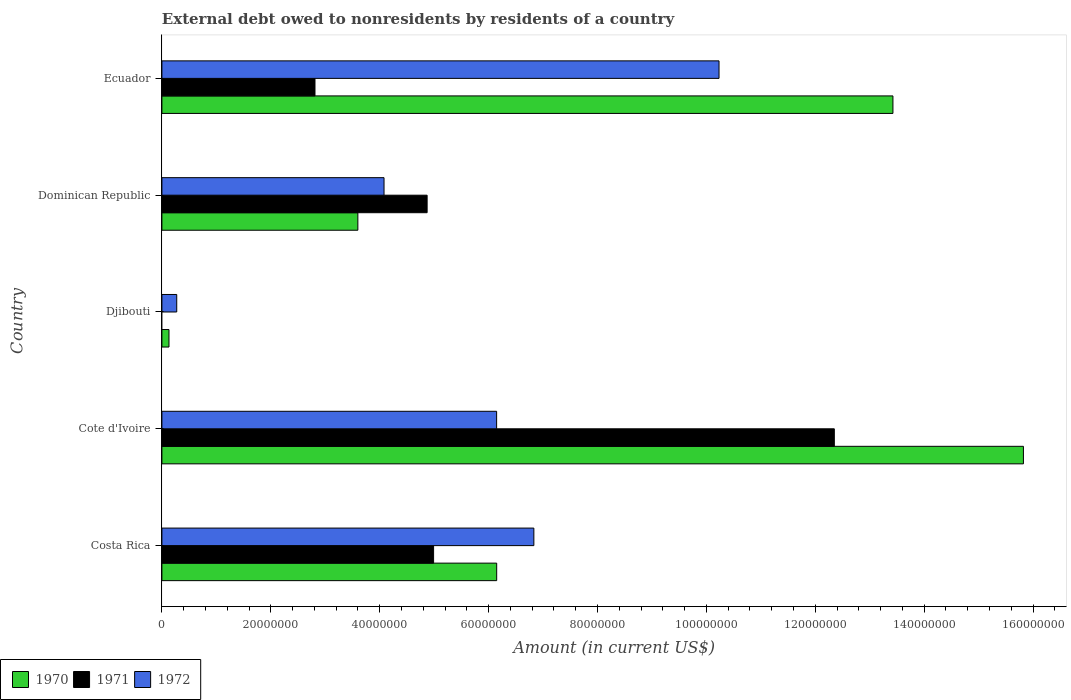Are the number of bars per tick equal to the number of legend labels?
Ensure brevity in your answer.  No. What is the label of the 2nd group of bars from the top?
Make the answer very short. Dominican Republic. In how many cases, is the number of bars for a given country not equal to the number of legend labels?
Your answer should be compact. 1. What is the external debt owed by residents in 1971 in Costa Rica?
Provide a short and direct response. 4.99e+07. Across all countries, what is the maximum external debt owed by residents in 1970?
Your answer should be compact. 1.58e+08. Across all countries, what is the minimum external debt owed by residents in 1972?
Provide a short and direct response. 2.72e+06. In which country was the external debt owed by residents in 1971 maximum?
Keep it short and to the point. Cote d'Ivoire. What is the total external debt owed by residents in 1972 in the graph?
Your answer should be very brief. 2.76e+08. What is the difference between the external debt owed by residents in 1971 in Dominican Republic and that in Ecuador?
Ensure brevity in your answer.  2.06e+07. What is the difference between the external debt owed by residents in 1970 in Djibouti and the external debt owed by residents in 1971 in Dominican Republic?
Keep it short and to the point. -4.74e+07. What is the average external debt owed by residents in 1972 per country?
Provide a short and direct response. 5.51e+07. What is the difference between the external debt owed by residents in 1971 and external debt owed by residents in 1972 in Ecuador?
Offer a very short reply. -7.42e+07. What is the ratio of the external debt owed by residents in 1972 in Djibouti to that in Ecuador?
Ensure brevity in your answer.  0.03. Is the external debt owed by residents in 1970 in Costa Rica less than that in Ecuador?
Your response must be concise. Yes. Is the difference between the external debt owed by residents in 1971 in Cote d'Ivoire and Ecuador greater than the difference between the external debt owed by residents in 1972 in Cote d'Ivoire and Ecuador?
Your response must be concise. Yes. What is the difference between the highest and the second highest external debt owed by residents in 1970?
Your answer should be compact. 2.40e+07. What is the difference between the highest and the lowest external debt owed by residents in 1971?
Your answer should be compact. 1.23e+08. In how many countries, is the external debt owed by residents in 1972 greater than the average external debt owed by residents in 1972 taken over all countries?
Give a very brief answer. 3. Is the sum of the external debt owed by residents in 1970 in Cote d'Ivoire and Ecuador greater than the maximum external debt owed by residents in 1972 across all countries?
Make the answer very short. Yes. How many bars are there?
Provide a succinct answer. 14. How many countries are there in the graph?
Your response must be concise. 5. Are the values on the major ticks of X-axis written in scientific E-notation?
Provide a succinct answer. No. Does the graph contain grids?
Provide a succinct answer. No. Where does the legend appear in the graph?
Give a very brief answer. Bottom left. What is the title of the graph?
Give a very brief answer. External debt owed to nonresidents by residents of a country. What is the Amount (in current US$) of 1970 in Costa Rica?
Ensure brevity in your answer.  6.15e+07. What is the Amount (in current US$) of 1971 in Costa Rica?
Your answer should be compact. 4.99e+07. What is the Amount (in current US$) of 1972 in Costa Rica?
Your answer should be compact. 6.83e+07. What is the Amount (in current US$) in 1970 in Cote d'Ivoire?
Your answer should be compact. 1.58e+08. What is the Amount (in current US$) in 1971 in Cote d'Ivoire?
Ensure brevity in your answer.  1.23e+08. What is the Amount (in current US$) of 1972 in Cote d'Ivoire?
Offer a very short reply. 6.15e+07. What is the Amount (in current US$) of 1970 in Djibouti?
Your answer should be very brief. 1.30e+06. What is the Amount (in current US$) of 1971 in Djibouti?
Provide a succinct answer. 0. What is the Amount (in current US$) of 1972 in Djibouti?
Make the answer very short. 2.72e+06. What is the Amount (in current US$) in 1970 in Dominican Republic?
Keep it short and to the point. 3.60e+07. What is the Amount (in current US$) of 1971 in Dominican Republic?
Ensure brevity in your answer.  4.87e+07. What is the Amount (in current US$) of 1972 in Dominican Republic?
Give a very brief answer. 4.08e+07. What is the Amount (in current US$) of 1970 in Ecuador?
Make the answer very short. 1.34e+08. What is the Amount (in current US$) in 1971 in Ecuador?
Give a very brief answer. 2.81e+07. What is the Amount (in current US$) in 1972 in Ecuador?
Provide a short and direct response. 1.02e+08. Across all countries, what is the maximum Amount (in current US$) of 1970?
Offer a terse response. 1.58e+08. Across all countries, what is the maximum Amount (in current US$) of 1971?
Your answer should be very brief. 1.23e+08. Across all countries, what is the maximum Amount (in current US$) in 1972?
Your answer should be compact. 1.02e+08. Across all countries, what is the minimum Amount (in current US$) of 1970?
Offer a terse response. 1.30e+06. Across all countries, what is the minimum Amount (in current US$) in 1971?
Give a very brief answer. 0. Across all countries, what is the minimum Amount (in current US$) of 1972?
Ensure brevity in your answer.  2.72e+06. What is the total Amount (in current US$) in 1970 in the graph?
Your answer should be compact. 3.91e+08. What is the total Amount (in current US$) of 1971 in the graph?
Give a very brief answer. 2.50e+08. What is the total Amount (in current US$) in 1972 in the graph?
Give a very brief answer. 2.76e+08. What is the difference between the Amount (in current US$) of 1970 in Costa Rica and that in Cote d'Ivoire?
Your answer should be compact. -9.67e+07. What is the difference between the Amount (in current US$) in 1971 in Costa Rica and that in Cote d'Ivoire?
Your response must be concise. -7.36e+07. What is the difference between the Amount (in current US$) in 1972 in Costa Rica and that in Cote d'Ivoire?
Ensure brevity in your answer.  6.84e+06. What is the difference between the Amount (in current US$) in 1970 in Costa Rica and that in Djibouti?
Make the answer very short. 6.02e+07. What is the difference between the Amount (in current US$) in 1972 in Costa Rica and that in Djibouti?
Your response must be concise. 6.56e+07. What is the difference between the Amount (in current US$) of 1970 in Costa Rica and that in Dominican Republic?
Provide a short and direct response. 2.55e+07. What is the difference between the Amount (in current US$) in 1971 in Costa Rica and that in Dominican Republic?
Ensure brevity in your answer.  1.19e+06. What is the difference between the Amount (in current US$) of 1972 in Costa Rica and that in Dominican Republic?
Offer a very short reply. 2.75e+07. What is the difference between the Amount (in current US$) in 1970 in Costa Rica and that in Ecuador?
Provide a short and direct response. -7.28e+07. What is the difference between the Amount (in current US$) of 1971 in Costa Rica and that in Ecuador?
Your answer should be compact. 2.18e+07. What is the difference between the Amount (in current US$) of 1972 in Costa Rica and that in Ecuador?
Provide a short and direct response. -3.40e+07. What is the difference between the Amount (in current US$) in 1970 in Cote d'Ivoire and that in Djibouti?
Ensure brevity in your answer.  1.57e+08. What is the difference between the Amount (in current US$) in 1972 in Cote d'Ivoire and that in Djibouti?
Provide a short and direct response. 5.88e+07. What is the difference between the Amount (in current US$) of 1970 in Cote d'Ivoire and that in Dominican Republic?
Give a very brief answer. 1.22e+08. What is the difference between the Amount (in current US$) in 1971 in Cote d'Ivoire and that in Dominican Republic?
Provide a short and direct response. 7.48e+07. What is the difference between the Amount (in current US$) in 1972 in Cote d'Ivoire and that in Dominican Republic?
Offer a very short reply. 2.07e+07. What is the difference between the Amount (in current US$) of 1970 in Cote d'Ivoire and that in Ecuador?
Offer a terse response. 2.40e+07. What is the difference between the Amount (in current US$) of 1971 in Cote d'Ivoire and that in Ecuador?
Offer a very short reply. 9.54e+07. What is the difference between the Amount (in current US$) of 1972 in Cote d'Ivoire and that in Ecuador?
Your answer should be very brief. -4.08e+07. What is the difference between the Amount (in current US$) of 1970 in Djibouti and that in Dominican Republic?
Offer a terse response. -3.47e+07. What is the difference between the Amount (in current US$) in 1972 in Djibouti and that in Dominican Republic?
Give a very brief answer. -3.81e+07. What is the difference between the Amount (in current US$) of 1970 in Djibouti and that in Ecuador?
Give a very brief answer. -1.33e+08. What is the difference between the Amount (in current US$) of 1972 in Djibouti and that in Ecuador?
Keep it short and to the point. -9.96e+07. What is the difference between the Amount (in current US$) in 1970 in Dominican Republic and that in Ecuador?
Your response must be concise. -9.83e+07. What is the difference between the Amount (in current US$) in 1971 in Dominican Republic and that in Ecuador?
Your answer should be very brief. 2.06e+07. What is the difference between the Amount (in current US$) in 1972 in Dominican Republic and that in Ecuador?
Keep it short and to the point. -6.15e+07. What is the difference between the Amount (in current US$) in 1970 in Costa Rica and the Amount (in current US$) in 1971 in Cote d'Ivoire?
Offer a very short reply. -6.20e+07. What is the difference between the Amount (in current US$) of 1970 in Costa Rica and the Amount (in current US$) of 1972 in Cote d'Ivoire?
Make the answer very short. 9000. What is the difference between the Amount (in current US$) in 1971 in Costa Rica and the Amount (in current US$) in 1972 in Cote d'Ivoire?
Ensure brevity in your answer.  -1.16e+07. What is the difference between the Amount (in current US$) in 1970 in Costa Rica and the Amount (in current US$) in 1972 in Djibouti?
Your answer should be very brief. 5.88e+07. What is the difference between the Amount (in current US$) of 1971 in Costa Rica and the Amount (in current US$) of 1972 in Djibouti?
Provide a succinct answer. 4.72e+07. What is the difference between the Amount (in current US$) of 1970 in Costa Rica and the Amount (in current US$) of 1971 in Dominican Republic?
Give a very brief answer. 1.28e+07. What is the difference between the Amount (in current US$) in 1970 in Costa Rica and the Amount (in current US$) in 1972 in Dominican Republic?
Your response must be concise. 2.07e+07. What is the difference between the Amount (in current US$) of 1971 in Costa Rica and the Amount (in current US$) of 1972 in Dominican Republic?
Offer a very short reply. 9.10e+06. What is the difference between the Amount (in current US$) in 1970 in Costa Rica and the Amount (in current US$) in 1971 in Ecuador?
Offer a terse response. 3.34e+07. What is the difference between the Amount (in current US$) of 1970 in Costa Rica and the Amount (in current US$) of 1972 in Ecuador?
Your answer should be compact. -4.08e+07. What is the difference between the Amount (in current US$) in 1971 in Costa Rica and the Amount (in current US$) in 1972 in Ecuador?
Your response must be concise. -5.24e+07. What is the difference between the Amount (in current US$) in 1970 in Cote d'Ivoire and the Amount (in current US$) in 1972 in Djibouti?
Your answer should be very brief. 1.55e+08. What is the difference between the Amount (in current US$) in 1971 in Cote d'Ivoire and the Amount (in current US$) in 1972 in Djibouti?
Ensure brevity in your answer.  1.21e+08. What is the difference between the Amount (in current US$) in 1970 in Cote d'Ivoire and the Amount (in current US$) in 1971 in Dominican Republic?
Keep it short and to the point. 1.10e+08. What is the difference between the Amount (in current US$) of 1970 in Cote d'Ivoire and the Amount (in current US$) of 1972 in Dominican Republic?
Offer a terse response. 1.17e+08. What is the difference between the Amount (in current US$) in 1971 in Cote d'Ivoire and the Amount (in current US$) in 1972 in Dominican Republic?
Provide a short and direct response. 8.27e+07. What is the difference between the Amount (in current US$) in 1970 in Cote d'Ivoire and the Amount (in current US$) in 1971 in Ecuador?
Provide a succinct answer. 1.30e+08. What is the difference between the Amount (in current US$) in 1970 in Cote d'Ivoire and the Amount (in current US$) in 1972 in Ecuador?
Your answer should be compact. 5.59e+07. What is the difference between the Amount (in current US$) of 1971 in Cote d'Ivoire and the Amount (in current US$) of 1972 in Ecuador?
Make the answer very short. 2.12e+07. What is the difference between the Amount (in current US$) of 1970 in Djibouti and the Amount (in current US$) of 1971 in Dominican Republic?
Offer a terse response. -4.74e+07. What is the difference between the Amount (in current US$) in 1970 in Djibouti and the Amount (in current US$) in 1972 in Dominican Republic?
Your answer should be compact. -3.95e+07. What is the difference between the Amount (in current US$) in 1970 in Djibouti and the Amount (in current US$) in 1971 in Ecuador?
Your answer should be very brief. -2.68e+07. What is the difference between the Amount (in current US$) in 1970 in Djibouti and the Amount (in current US$) in 1972 in Ecuador?
Offer a terse response. -1.01e+08. What is the difference between the Amount (in current US$) of 1970 in Dominican Republic and the Amount (in current US$) of 1971 in Ecuador?
Offer a terse response. 7.88e+06. What is the difference between the Amount (in current US$) in 1970 in Dominican Republic and the Amount (in current US$) in 1972 in Ecuador?
Provide a succinct answer. -6.63e+07. What is the difference between the Amount (in current US$) in 1971 in Dominican Republic and the Amount (in current US$) in 1972 in Ecuador?
Your answer should be very brief. -5.36e+07. What is the average Amount (in current US$) in 1970 per country?
Provide a short and direct response. 7.83e+07. What is the average Amount (in current US$) of 1971 per country?
Ensure brevity in your answer.  5.00e+07. What is the average Amount (in current US$) of 1972 per country?
Your answer should be very brief. 5.51e+07. What is the difference between the Amount (in current US$) in 1970 and Amount (in current US$) in 1971 in Costa Rica?
Your response must be concise. 1.16e+07. What is the difference between the Amount (in current US$) of 1970 and Amount (in current US$) of 1972 in Costa Rica?
Offer a terse response. -6.83e+06. What is the difference between the Amount (in current US$) of 1971 and Amount (in current US$) of 1972 in Costa Rica?
Make the answer very short. -1.84e+07. What is the difference between the Amount (in current US$) in 1970 and Amount (in current US$) in 1971 in Cote d'Ivoire?
Offer a terse response. 3.47e+07. What is the difference between the Amount (in current US$) in 1970 and Amount (in current US$) in 1972 in Cote d'Ivoire?
Offer a terse response. 9.67e+07. What is the difference between the Amount (in current US$) in 1971 and Amount (in current US$) in 1972 in Cote d'Ivoire?
Provide a succinct answer. 6.20e+07. What is the difference between the Amount (in current US$) of 1970 and Amount (in current US$) of 1972 in Djibouti?
Your answer should be very brief. -1.42e+06. What is the difference between the Amount (in current US$) of 1970 and Amount (in current US$) of 1971 in Dominican Republic?
Offer a terse response. -1.27e+07. What is the difference between the Amount (in current US$) in 1970 and Amount (in current US$) in 1972 in Dominican Republic?
Keep it short and to the point. -4.81e+06. What is the difference between the Amount (in current US$) in 1971 and Amount (in current US$) in 1972 in Dominican Republic?
Your response must be concise. 7.91e+06. What is the difference between the Amount (in current US$) of 1970 and Amount (in current US$) of 1971 in Ecuador?
Ensure brevity in your answer.  1.06e+08. What is the difference between the Amount (in current US$) of 1970 and Amount (in current US$) of 1972 in Ecuador?
Your response must be concise. 3.19e+07. What is the difference between the Amount (in current US$) of 1971 and Amount (in current US$) of 1972 in Ecuador?
Offer a very short reply. -7.42e+07. What is the ratio of the Amount (in current US$) in 1970 in Costa Rica to that in Cote d'Ivoire?
Offer a very short reply. 0.39. What is the ratio of the Amount (in current US$) in 1971 in Costa Rica to that in Cote d'Ivoire?
Your answer should be compact. 0.4. What is the ratio of the Amount (in current US$) in 1972 in Costa Rica to that in Cote d'Ivoire?
Your answer should be compact. 1.11. What is the ratio of the Amount (in current US$) in 1970 in Costa Rica to that in Djibouti?
Make the answer very short. 47.3. What is the ratio of the Amount (in current US$) in 1972 in Costa Rica to that in Djibouti?
Make the answer very short. 25.09. What is the ratio of the Amount (in current US$) in 1970 in Costa Rica to that in Dominican Republic?
Give a very brief answer. 1.71. What is the ratio of the Amount (in current US$) of 1971 in Costa Rica to that in Dominican Republic?
Provide a short and direct response. 1.02. What is the ratio of the Amount (in current US$) of 1972 in Costa Rica to that in Dominican Republic?
Your answer should be compact. 1.67. What is the ratio of the Amount (in current US$) in 1970 in Costa Rica to that in Ecuador?
Make the answer very short. 0.46. What is the ratio of the Amount (in current US$) of 1971 in Costa Rica to that in Ecuador?
Your answer should be very brief. 1.77. What is the ratio of the Amount (in current US$) of 1972 in Costa Rica to that in Ecuador?
Your answer should be very brief. 0.67. What is the ratio of the Amount (in current US$) in 1970 in Cote d'Ivoire to that in Djibouti?
Keep it short and to the point. 121.71. What is the ratio of the Amount (in current US$) of 1972 in Cote d'Ivoire to that in Djibouti?
Your response must be concise. 22.58. What is the ratio of the Amount (in current US$) in 1970 in Cote d'Ivoire to that in Dominican Republic?
Provide a short and direct response. 4.4. What is the ratio of the Amount (in current US$) in 1971 in Cote d'Ivoire to that in Dominican Republic?
Offer a very short reply. 2.54. What is the ratio of the Amount (in current US$) of 1972 in Cote d'Ivoire to that in Dominican Republic?
Make the answer very short. 1.51. What is the ratio of the Amount (in current US$) of 1970 in Cote d'Ivoire to that in Ecuador?
Your answer should be very brief. 1.18. What is the ratio of the Amount (in current US$) of 1971 in Cote d'Ivoire to that in Ecuador?
Provide a succinct answer. 4.39. What is the ratio of the Amount (in current US$) in 1972 in Cote d'Ivoire to that in Ecuador?
Give a very brief answer. 0.6. What is the ratio of the Amount (in current US$) of 1970 in Djibouti to that in Dominican Republic?
Give a very brief answer. 0.04. What is the ratio of the Amount (in current US$) in 1972 in Djibouti to that in Dominican Republic?
Keep it short and to the point. 0.07. What is the ratio of the Amount (in current US$) of 1970 in Djibouti to that in Ecuador?
Provide a short and direct response. 0.01. What is the ratio of the Amount (in current US$) of 1972 in Djibouti to that in Ecuador?
Make the answer very short. 0.03. What is the ratio of the Amount (in current US$) of 1970 in Dominican Republic to that in Ecuador?
Ensure brevity in your answer.  0.27. What is the ratio of the Amount (in current US$) in 1971 in Dominican Republic to that in Ecuador?
Your answer should be very brief. 1.73. What is the ratio of the Amount (in current US$) of 1972 in Dominican Republic to that in Ecuador?
Provide a short and direct response. 0.4. What is the difference between the highest and the second highest Amount (in current US$) in 1970?
Offer a terse response. 2.40e+07. What is the difference between the highest and the second highest Amount (in current US$) in 1971?
Ensure brevity in your answer.  7.36e+07. What is the difference between the highest and the second highest Amount (in current US$) of 1972?
Ensure brevity in your answer.  3.40e+07. What is the difference between the highest and the lowest Amount (in current US$) of 1970?
Your response must be concise. 1.57e+08. What is the difference between the highest and the lowest Amount (in current US$) of 1971?
Provide a short and direct response. 1.23e+08. What is the difference between the highest and the lowest Amount (in current US$) in 1972?
Ensure brevity in your answer.  9.96e+07. 